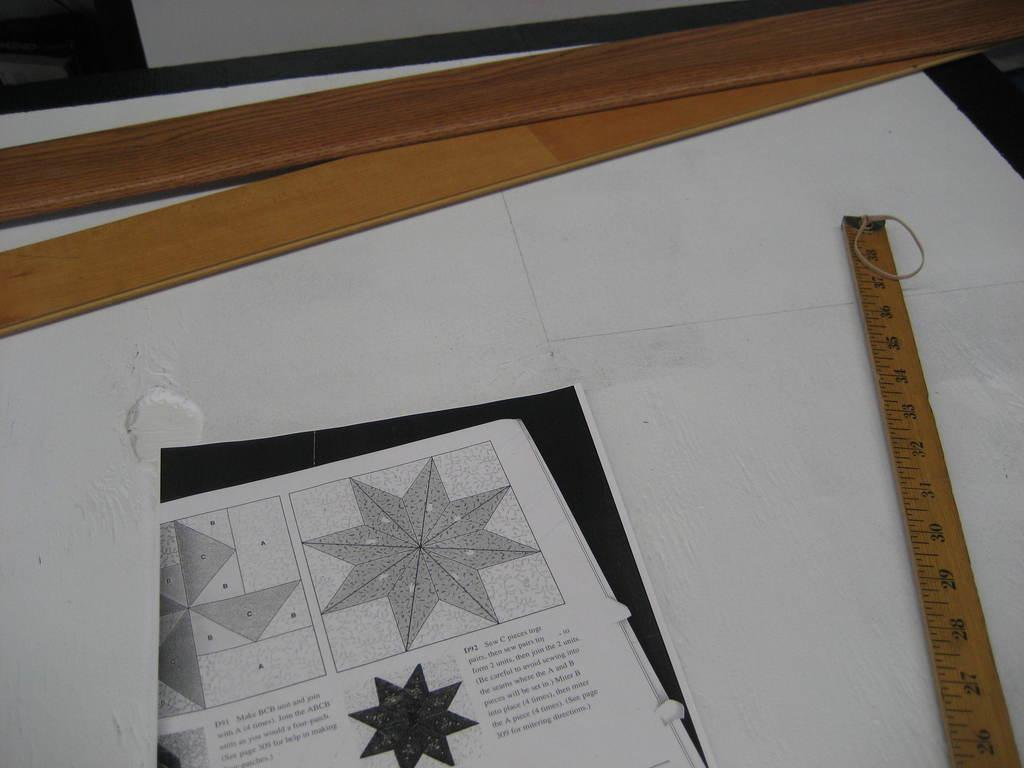What is the first word you see?
Your answer should be very brief. Unanswerable. 